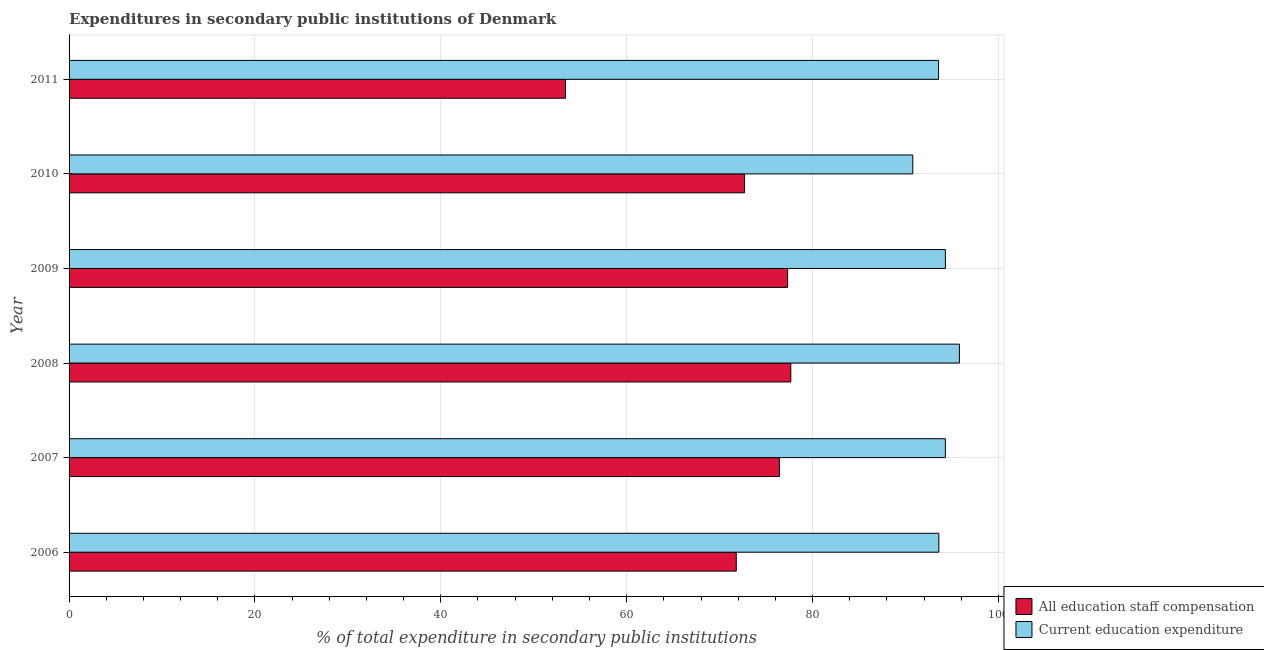How many different coloured bars are there?
Offer a terse response. 2. How many bars are there on the 2nd tick from the top?
Provide a short and direct response. 2. How many bars are there on the 6th tick from the bottom?
Your response must be concise. 2. What is the label of the 4th group of bars from the top?
Your answer should be compact. 2008. In how many cases, is the number of bars for a given year not equal to the number of legend labels?
Offer a terse response. 0. What is the expenditure in education in 2006?
Ensure brevity in your answer.  93.59. Across all years, what is the maximum expenditure in staff compensation?
Ensure brevity in your answer.  77.66. Across all years, what is the minimum expenditure in staff compensation?
Keep it short and to the point. 53.42. What is the total expenditure in education in the graph?
Your answer should be compact. 562.34. What is the difference between the expenditure in staff compensation in 2007 and that in 2011?
Ensure brevity in your answer.  23.01. What is the difference between the expenditure in education in 2011 and the expenditure in staff compensation in 2010?
Your response must be concise. 20.88. What is the average expenditure in staff compensation per year?
Your answer should be compact. 71.55. In the year 2010, what is the difference between the expenditure in education and expenditure in staff compensation?
Your answer should be very brief. 18.11. In how many years, is the expenditure in education greater than 48 %?
Ensure brevity in your answer.  6. What is the ratio of the expenditure in staff compensation in 2006 to that in 2008?
Offer a very short reply. 0.92. Is the expenditure in education in 2006 less than that in 2011?
Offer a terse response. No. What is the difference between the highest and the second highest expenditure in staff compensation?
Make the answer very short. 0.34. What is the difference between the highest and the lowest expenditure in education?
Ensure brevity in your answer.  5.02. In how many years, is the expenditure in education greater than the average expenditure in education taken over all years?
Offer a very short reply. 3. What does the 1st bar from the top in 2006 represents?
Give a very brief answer. Current education expenditure. What does the 2nd bar from the bottom in 2007 represents?
Provide a short and direct response. Current education expenditure. How many bars are there?
Ensure brevity in your answer.  12. Are all the bars in the graph horizontal?
Offer a terse response. Yes. Does the graph contain grids?
Ensure brevity in your answer.  Yes. What is the title of the graph?
Your response must be concise. Expenditures in secondary public institutions of Denmark. Does "Public funds" appear as one of the legend labels in the graph?
Keep it short and to the point. No. What is the label or title of the X-axis?
Your response must be concise. % of total expenditure in secondary public institutions. What is the label or title of the Y-axis?
Your response must be concise. Year. What is the % of total expenditure in secondary public institutions of All education staff compensation in 2006?
Offer a terse response. 71.79. What is the % of total expenditure in secondary public institutions in Current education expenditure in 2006?
Your answer should be very brief. 93.59. What is the % of total expenditure in secondary public institutions of All education staff compensation in 2007?
Offer a terse response. 76.43. What is the % of total expenditure in secondary public institutions in Current education expenditure in 2007?
Keep it short and to the point. 94.3. What is the % of total expenditure in secondary public institutions in All education staff compensation in 2008?
Your answer should be very brief. 77.66. What is the % of total expenditure in secondary public institutions of Current education expenditure in 2008?
Your answer should be very brief. 95.81. What is the % of total expenditure in secondary public institutions in All education staff compensation in 2009?
Make the answer very short. 77.32. What is the % of total expenditure in secondary public institutions in Current education expenditure in 2009?
Give a very brief answer. 94.3. What is the % of total expenditure in secondary public institutions in All education staff compensation in 2010?
Ensure brevity in your answer.  72.68. What is the % of total expenditure in secondary public institutions of Current education expenditure in 2010?
Offer a terse response. 90.79. What is the % of total expenditure in secondary public institutions of All education staff compensation in 2011?
Your answer should be very brief. 53.42. What is the % of total expenditure in secondary public institutions of Current education expenditure in 2011?
Provide a short and direct response. 93.56. Across all years, what is the maximum % of total expenditure in secondary public institutions in All education staff compensation?
Your answer should be very brief. 77.66. Across all years, what is the maximum % of total expenditure in secondary public institutions of Current education expenditure?
Provide a short and direct response. 95.81. Across all years, what is the minimum % of total expenditure in secondary public institutions of All education staff compensation?
Your answer should be very brief. 53.42. Across all years, what is the minimum % of total expenditure in secondary public institutions in Current education expenditure?
Your response must be concise. 90.79. What is the total % of total expenditure in secondary public institutions in All education staff compensation in the graph?
Your response must be concise. 429.31. What is the total % of total expenditure in secondary public institutions of Current education expenditure in the graph?
Keep it short and to the point. 562.34. What is the difference between the % of total expenditure in secondary public institutions in All education staff compensation in 2006 and that in 2007?
Your answer should be compact. -4.64. What is the difference between the % of total expenditure in secondary public institutions in Current education expenditure in 2006 and that in 2007?
Provide a succinct answer. -0.7. What is the difference between the % of total expenditure in secondary public institutions of All education staff compensation in 2006 and that in 2008?
Make the answer very short. -5.87. What is the difference between the % of total expenditure in secondary public institutions of Current education expenditure in 2006 and that in 2008?
Offer a terse response. -2.21. What is the difference between the % of total expenditure in secondary public institutions in All education staff compensation in 2006 and that in 2009?
Give a very brief answer. -5.53. What is the difference between the % of total expenditure in secondary public institutions in Current education expenditure in 2006 and that in 2009?
Ensure brevity in your answer.  -0.7. What is the difference between the % of total expenditure in secondary public institutions in All education staff compensation in 2006 and that in 2010?
Keep it short and to the point. -0.89. What is the difference between the % of total expenditure in secondary public institutions of Current education expenditure in 2006 and that in 2010?
Offer a terse response. 2.81. What is the difference between the % of total expenditure in secondary public institutions of All education staff compensation in 2006 and that in 2011?
Ensure brevity in your answer.  18.38. What is the difference between the % of total expenditure in secondary public institutions of Current education expenditure in 2006 and that in 2011?
Your answer should be very brief. 0.03. What is the difference between the % of total expenditure in secondary public institutions of All education staff compensation in 2007 and that in 2008?
Your answer should be compact. -1.23. What is the difference between the % of total expenditure in secondary public institutions of Current education expenditure in 2007 and that in 2008?
Ensure brevity in your answer.  -1.51. What is the difference between the % of total expenditure in secondary public institutions of All education staff compensation in 2007 and that in 2009?
Offer a terse response. -0.89. What is the difference between the % of total expenditure in secondary public institutions of Current education expenditure in 2007 and that in 2009?
Your answer should be very brief. -0. What is the difference between the % of total expenditure in secondary public institutions in All education staff compensation in 2007 and that in 2010?
Your answer should be very brief. 3.75. What is the difference between the % of total expenditure in secondary public institutions of Current education expenditure in 2007 and that in 2010?
Give a very brief answer. 3.51. What is the difference between the % of total expenditure in secondary public institutions of All education staff compensation in 2007 and that in 2011?
Provide a short and direct response. 23.01. What is the difference between the % of total expenditure in secondary public institutions in Current education expenditure in 2007 and that in 2011?
Your answer should be compact. 0.73. What is the difference between the % of total expenditure in secondary public institutions in All education staff compensation in 2008 and that in 2009?
Make the answer very short. 0.34. What is the difference between the % of total expenditure in secondary public institutions of Current education expenditure in 2008 and that in 2009?
Provide a succinct answer. 1.51. What is the difference between the % of total expenditure in secondary public institutions of All education staff compensation in 2008 and that in 2010?
Keep it short and to the point. 4.98. What is the difference between the % of total expenditure in secondary public institutions of Current education expenditure in 2008 and that in 2010?
Provide a succinct answer. 5.02. What is the difference between the % of total expenditure in secondary public institutions in All education staff compensation in 2008 and that in 2011?
Give a very brief answer. 24.25. What is the difference between the % of total expenditure in secondary public institutions of Current education expenditure in 2008 and that in 2011?
Offer a very short reply. 2.25. What is the difference between the % of total expenditure in secondary public institutions in All education staff compensation in 2009 and that in 2010?
Offer a very short reply. 4.64. What is the difference between the % of total expenditure in secondary public institutions in Current education expenditure in 2009 and that in 2010?
Your answer should be compact. 3.51. What is the difference between the % of total expenditure in secondary public institutions in All education staff compensation in 2009 and that in 2011?
Keep it short and to the point. 23.9. What is the difference between the % of total expenditure in secondary public institutions in Current education expenditure in 2009 and that in 2011?
Your answer should be very brief. 0.74. What is the difference between the % of total expenditure in secondary public institutions of All education staff compensation in 2010 and that in 2011?
Provide a succinct answer. 19.27. What is the difference between the % of total expenditure in secondary public institutions in Current education expenditure in 2010 and that in 2011?
Provide a succinct answer. -2.77. What is the difference between the % of total expenditure in secondary public institutions in All education staff compensation in 2006 and the % of total expenditure in secondary public institutions in Current education expenditure in 2007?
Keep it short and to the point. -22.5. What is the difference between the % of total expenditure in secondary public institutions in All education staff compensation in 2006 and the % of total expenditure in secondary public institutions in Current education expenditure in 2008?
Provide a short and direct response. -24.01. What is the difference between the % of total expenditure in secondary public institutions in All education staff compensation in 2006 and the % of total expenditure in secondary public institutions in Current education expenditure in 2009?
Your answer should be compact. -22.5. What is the difference between the % of total expenditure in secondary public institutions of All education staff compensation in 2006 and the % of total expenditure in secondary public institutions of Current education expenditure in 2010?
Give a very brief answer. -18.99. What is the difference between the % of total expenditure in secondary public institutions of All education staff compensation in 2006 and the % of total expenditure in secondary public institutions of Current education expenditure in 2011?
Offer a terse response. -21.77. What is the difference between the % of total expenditure in secondary public institutions in All education staff compensation in 2007 and the % of total expenditure in secondary public institutions in Current education expenditure in 2008?
Offer a terse response. -19.38. What is the difference between the % of total expenditure in secondary public institutions of All education staff compensation in 2007 and the % of total expenditure in secondary public institutions of Current education expenditure in 2009?
Your response must be concise. -17.87. What is the difference between the % of total expenditure in secondary public institutions of All education staff compensation in 2007 and the % of total expenditure in secondary public institutions of Current education expenditure in 2010?
Offer a terse response. -14.36. What is the difference between the % of total expenditure in secondary public institutions in All education staff compensation in 2007 and the % of total expenditure in secondary public institutions in Current education expenditure in 2011?
Offer a very short reply. -17.13. What is the difference between the % of total expenditure in secondary public institutions in All education staff compensation in 2008 and the % of total expenditure in secondary public institutions in Current education expenditure in 2009?
Your response must be concise. -16.63. What is the difference between the % of total expenditure in secondary public institutions in All education staff compensation in 2008 and the % of total expenditure in secondary public institutions in Current education expenditure in 2010?
Your response must be concise. -13.12. What is the difference between the % of total expenditure in secondary public institutions of All education staff compensation in 2008 and the % of total expenditure in secondary public institutions of Current education expenditure in 2011?
Your answer should be very brief. -15.9. What is the difference between the % of total expenditure in secondary public institutions of All education staff compensation in 2009 and the % of total expenditure in secondary public institutions of Current education expenditure in 2010?
Keep it short and to the point. -13.47. What is the difference between the % of total expenditure in secondary public institutions in All education staff compensation in 2009 and the % of total expenditure in secondary public institutions in Current education expenditure in 2011?
Offer a terse response. -16.24. What is the difference between the % of total expenditure in secondary public institutions of All education staff compensation in 2010 and the % of total expenditure in secondary public institutions of Current education expenditure in 2011?
Provide a short and direct response. -20.88. What is the average % of total expenditure in secondary public institutions of All education staff compensation per year?
Provide a short and direct response. 71.55. What is the average % of total expenditure in secondary public institutions in Current education expenditure per year?
Keep it short and to the point. 93.72. In the year 2006, what is the difference between the % of total expenditure in secondary public institutions in All education staff compensation and % of total expenditure in secondary public institutions in Current education expenditure?
Your answer should be very brief. -21.8. In the year 2007, what is the difference between the % of total expenditure in secondary public institutions in All education staff compensation and % of total expenditure in secondary public institutions in Current education expenditure?
Provide a succinct answer. -17.86. In the year 2008, what is the difference between the % of total expenditure in secondary public institutions of All education staff compensation and % of total expenditure in secondary public institutions of Current education expenditure?
Keep it short and to the point. -18.14. In the year 2009, what is the difference between the % of total expenditure in secondary public institutions in All education staff compensation and % of total expenditure in secondary public institutions in Current education expenditure?
Provide a succinct answer. -16.98. In the year 2010, what is the difference between the % of total expenditure in secondary public institutions of All education staff compensation and % of total expenditure in secondary public institutions of Current education expenditure?
Offer a terse response. -18.11. In the year 2011, what is the difference between the % of total expenditure in secondary public institutions in All education staff compensation and % of total expenditure in secondary public institutions in Current education expenditure?
Your answer should be very brief. -40.15. What is the ratio of the % of total expenditure in secondary public institutions of All education staff compensation in 2006 to that in 2007?
Give a very brief answer. 0.94. What is the ratio of the % of total expenditure in secondary public institutions in Current education expenditure in 2006 to that in 2007?
Your response must be concise. 0.99. What is the ratio of the % of total expenditure in secondary public institutions of All education staff compensation in 2006 to that in 2008?
Make the answer very short. 0.92. What is the ratio of the % of total expenditure in secondary public institutions of Current education expenditure in 2006 to that in 2008?
Offer a terse response. 0.98. What is the ratio of the % of total expenditure in secondary public institutions of All education staff compensation in 2006 to that in 2009?
Give a very brief answer. 0.93. What is the ratio of the % of total expenditure in secondary public institutions in All education staff compensation in 2006 to that in 2010?
Make the answer very short. 0.99. What is the ratio of the % of total expenditure in secondary public institutions in Current education expenditure in 2006 to that in 2010?
Provide a short and direct response. 1.03. What is the ratio of the % of total expenditure in secondary public institutions of All education staff compensation in 2006 to that in 2011?
Your answer should be very brief. 1.34. What is the ratio of the % of total expenditure in secondary public institutions in All education staff compensation in 2007 to that in 2008?
Offer a very short reply. 0.98. What is the ratio of the % of total expenditure in secondary public institutions in Current education expenditure in 2007 to that in 2008?
Ensure brevity in your answer.  0.98. What is the ratio of the % of total expenditure in secondary public institutions in All education staff compensation in 2007 to that in 2009?
Your response must be concise. 0.99. What is the ratio of the % of total expenditure in secondary public institutions in Current education expenditure in 2007 to that in 2009?
Your answer should be compact. 1. What is the ratio of the % of total expenditure in secondary public institutions in All education staff compensation in 2007 to that in 2010?
Offer a very short reply. 1.05. What is the ratio of the % of total expenditure in secondary public institutions of Current education expenditure in 2007 to that in 2010?
Your answer should be compact. 1.04. What is the ratio of the % of total expenditure in secondary public institutions in All education staff compensation in 2007 to that in 2011?
Provide a succinct answer. 1.43. What is the ratio of the % of total expenditure in secondary public institutions in All education staff compensation in 2008 to that in 2009?
Keep it short and to the point. 1. What is the ratio of the % of total expenditure in secondary public institutions of Current education expenditure in 2008 to that in 2009?
Your answer should be compact. 1.02. What is the ratio of the % of total expenditure in secondary public institutions of All education staff compensation in 2008 to that in 2010?
Your response must be concise. 1.07. What is the ratio of the % of total expenditure in secondary public institutions of Current education expenditure in 2008 to that in 2010?
Your response must be concise. 1.06. What is the ratio of the % of total expenditure in secondary public institutions in All education staff compensation in 2008 to that in 2011?
Your answer should be compact. 1.45. What is the ratio of the % of total expenditure in secondary public institutions of Current education expenditure in 2008 to that in 2011?
Your answer should be very brief. 1.02. What is the ratio of the % of total expenditure in secondary public institutions in All education staff compensation in 2009 to that in 2010?
Ensure brevity in your answer.  1.06. What is the ratio of the % of total expenditure in secondary public institutions in Current education expenditure in 2009 to that in 2010?
Make the answer very short. 1.04. What is the ratio of the % of total expenditure in secondary public institutions in All education staff compensation in 2009 to that in 2011?
Ensure brevity in your answer.  1.45. What is the ratio of the % of total expenditure in secondary public institutions in Current education expenditure in 2009 to that in 2011?
Ensure brevity in your answer.  1.01. What is the ratio of the % of total expenditure in secondary public institutions of All education staff compensation in 2010 to that in 2011?
Ensure brevity in your answer.  1.36. What is the ratio of the % of total expenditure in secondary public institutions of Current education expenditure in 2010 to that in 2011?
Provide a short and direct response. 0.97. What is the difference between the highest and the second highest % of total expenditure in secondary public institutions in All education staff compensation?
Offer a very short reply. 0.34. What is the difference between the highest and the second highest % of total expenditure in secondary public institutions in Current education expenditure?
Offer a very short reply. 1.51. What is the difference between the highest and the lowest % of total expenditure in secondary public institutions of All education staff compensation?
Your answer should be compact. 24.25. What is the difference between the highest and the lowest % of total expenditure in secondary public institutions in Current education expenditure?
Ensure brevity in your answer.  5.02. 